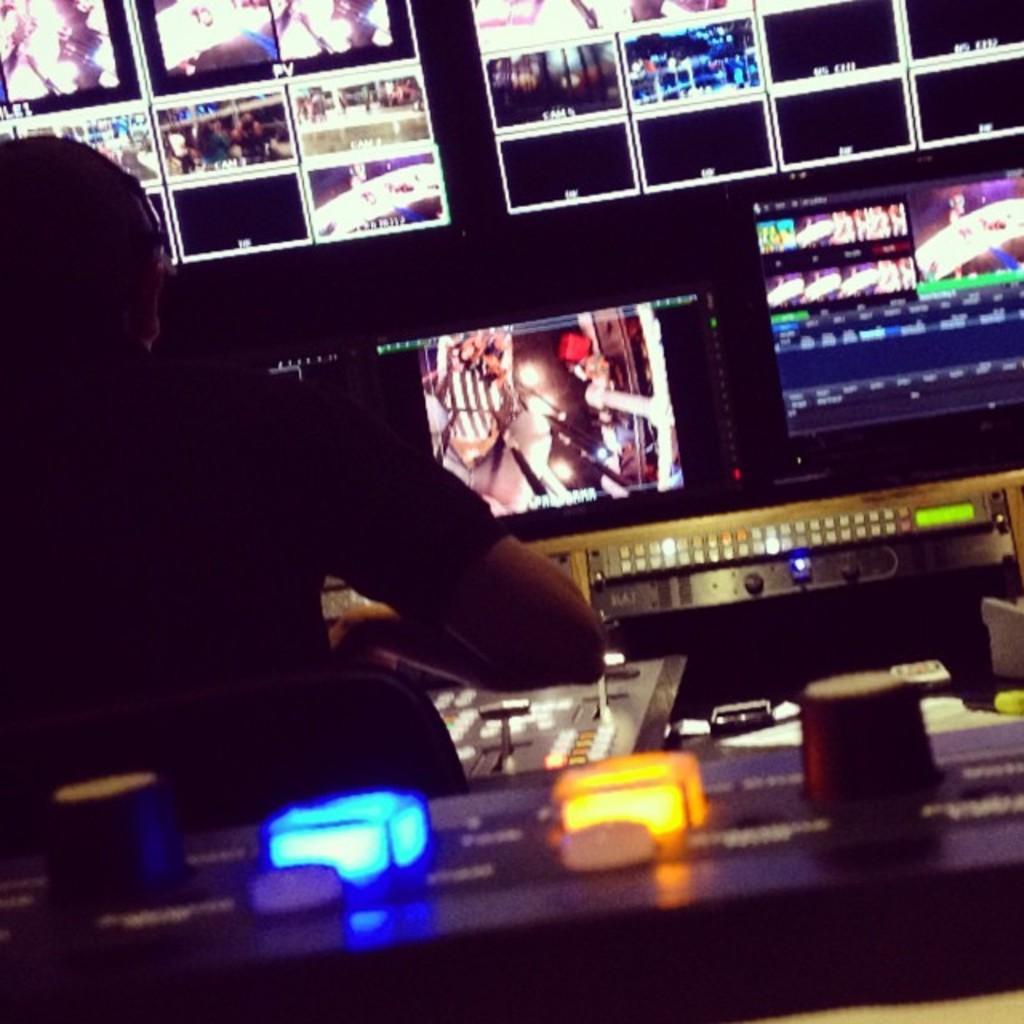Could you give a brief overview of what you see in this image? In this picture we can see the man sitting in the front and watching the CCTV footage on the television screen. In the front bottom side there is a yellow and blue light on the electronic equipment board. 